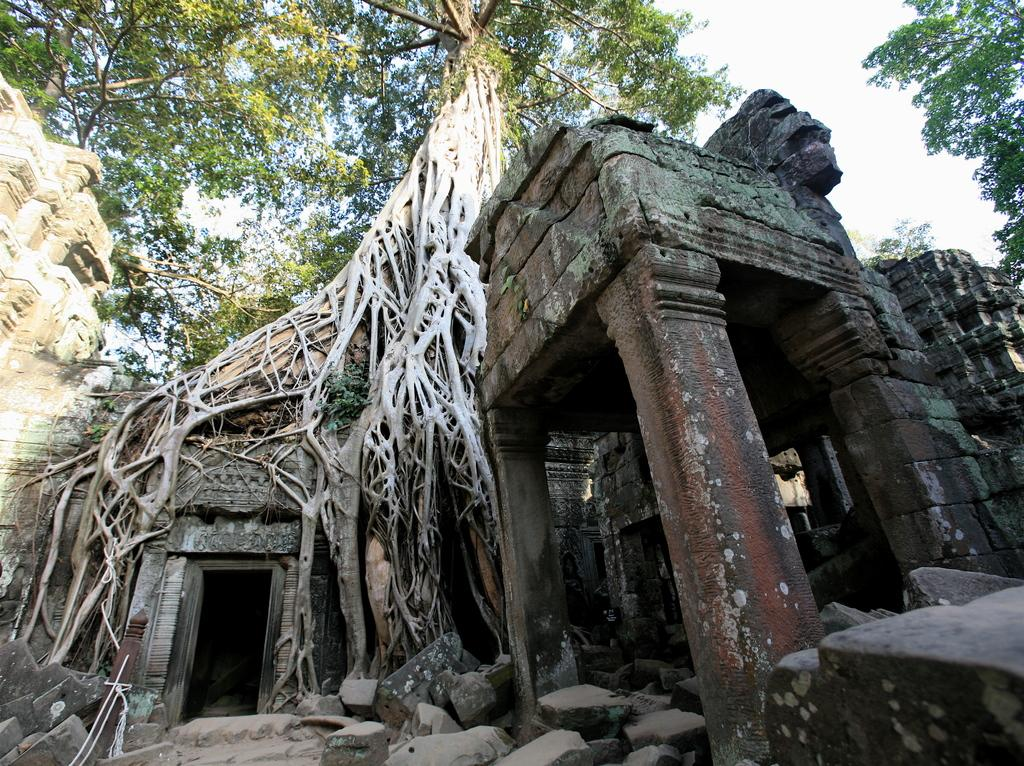What is the main subject of the image? There is a monument in the image. What can be seen in the foreground of the image? There are stones in the foreground of the image. What type of vegetation is visible at the top of the image? There are trees at the top of the image. How would you describe the weather in the image? The sky is sunny in the image. How many beginner cows are grazing in the image? There are no cows present in the image, let alone beginner cows. 